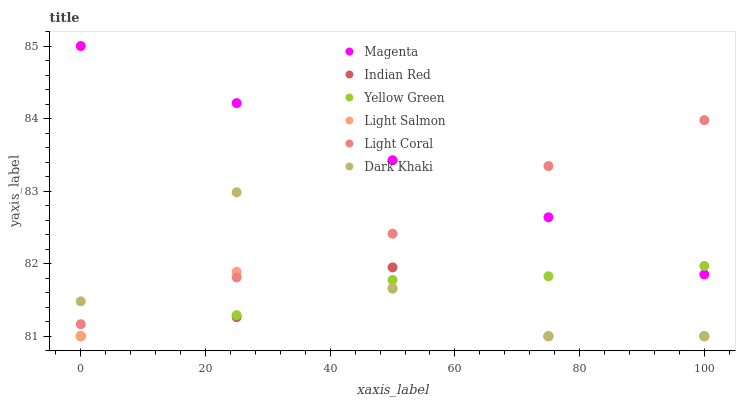Does Indian Red have the minimum area under the curve?
Answer yes or no. Yes. Does Magenta have the maximum area under the curve?
Answer yes or no. Yes. Does Light Salmon have the minimum area under the curve?
Answer yes or no. No. Does Light Salmon have the maximum area under the curve?
Answer yes or no. No. Is Magenta the smoothest?
Answer yes or no. Yes. Is Dark Khaki the roughest?
Answer yes or no. Yes. Is Light Salmon the smoothest?
Answer yes or no. No. Is Light Salmon the roughest?
Answer yes or no. No. Does Dark Khaki have the lowest value?
Answer yes or no. Yes. Does Yellow Green have the lowest value?
Answer yes or no. No. Does Magenta have the highest value?
Answer yes or no. Yes. Does Yellow Green have the highest value?
Answer yes or no. No. Is Indian Red less than Magenta?
Answer yes or no. Yes. Is Light Coral greater than Yellow Green?
Answer yes or no. Yes. Does Dark Khaki intersect Indian Red?
Answer yes or no. Yes. Is Dark Khaki less than Indian Red?
Answer yes or no. No. Is Dark Khaki greater than Indian Red?
Answer yes or no. No. Does Indian Red intersect Magenta?
Answer yes or no. No. 